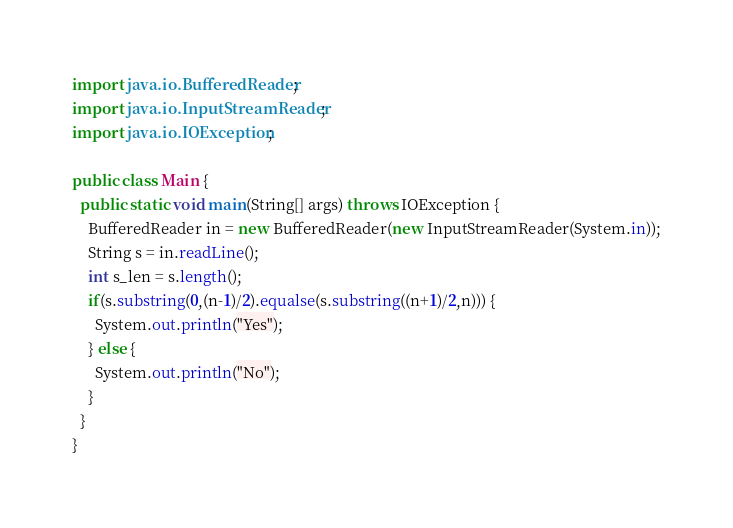<code> <loc_0><loc_0><loc_500><loc_500><_Java_>import java.io.BufferedReader;
import java.io.InputStreamReader;
import java.io.IOException;

public class Main {
  public static void main(String[] args) throws IOException {
    BufferedReader in = new BufferedReader(new InputStreamReader(System.in));
    String s = in.readLine();
    int s_len = s.length();
    if(s.substring(0,(n-1)/2).equalse(s.substring((n+1)/2,n))) {
      System.out.println("Yes");
    } else {
      System.out.println("No");
    }
  }
}</code> 